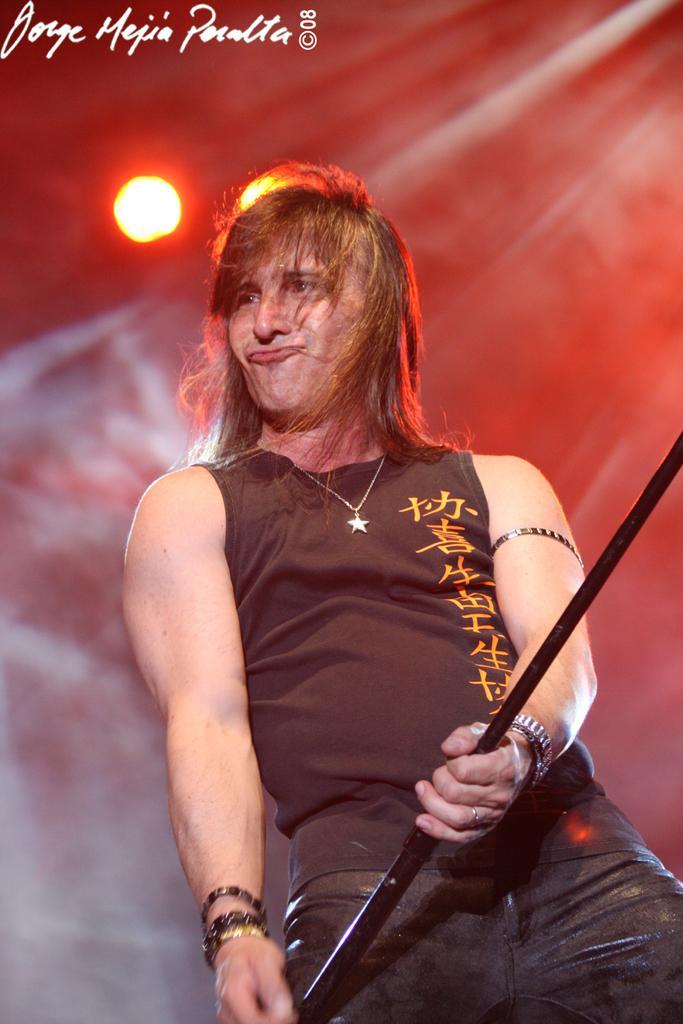In one or two sentences, can you explain what this image depicts? In this picture we can see a man, he is holding a metal rod in his hand, in the background we can find lights. 